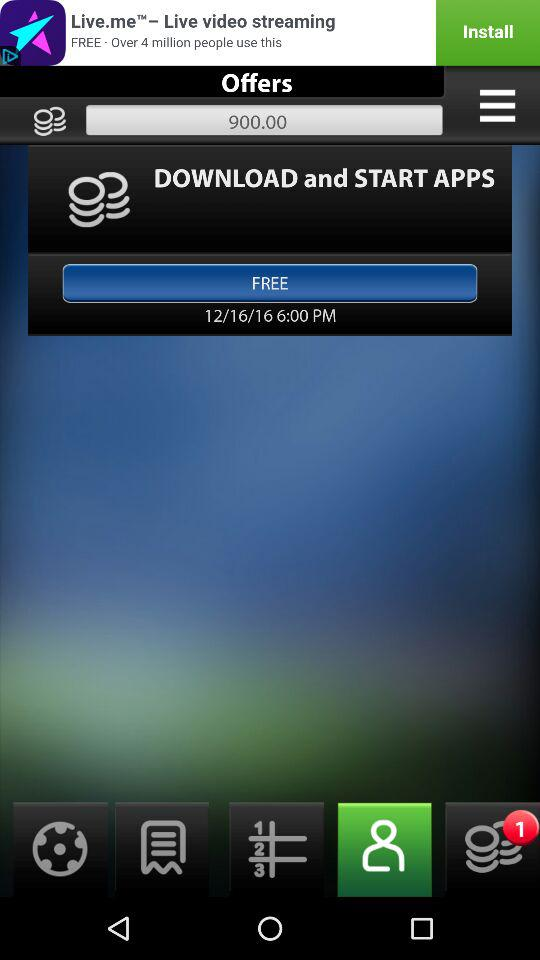What is the date and time of this transaction?
Answer the question using a single word or phrase. 12/16/16 6:00 PM 